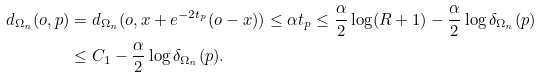Convert formula to latex. <formula><loc_0><loc_0><loc_500><loc_500>d _ { \Omega _ { n } } ( o , p ) & = d _ { \Omega _ { n } } ( o , x + e ^ { - 2 t _ { p } } ( o - x ) ) \leq \alpha t _ { p } \leq \frac { \alpha } { 2 } \log ( R + 1 ) - \frac { \alpha } { 2 } \log \delta _ { \Omega _ { n } } ( p ) \\ & \leq C _ { 1 } - \frac { \alpha } { 2 } \log \delta _ { \Omega _ { n } } ( p ) .</formula> 